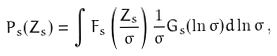Convert formula to latex. <formula><loc_0><loc_0><loc_500><loc_500>P _ { s } ( Z _ { s } ) = \int F _ { s } \left ( \frac { Z _ { s } } { \sigma } \right ) \frac { 1 } { \sigma } G _ { s } ( \ln \sigma ) d \ln \sigma \, ,</formula> 